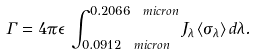Convert formula to latex. <formula><loc_0><loc_0><loc_500><loc_500>\Gamma = 4 \pi \epsilon \, \int _ { 0 . 0 9 1 2 \ m i c r o n } ^ { 0 . 2 0 6 6 \ m i c r o n } J _ { \lambda } \, \langle \sigma _ { \lambda } \rangle \, d \lambda .</formula> 